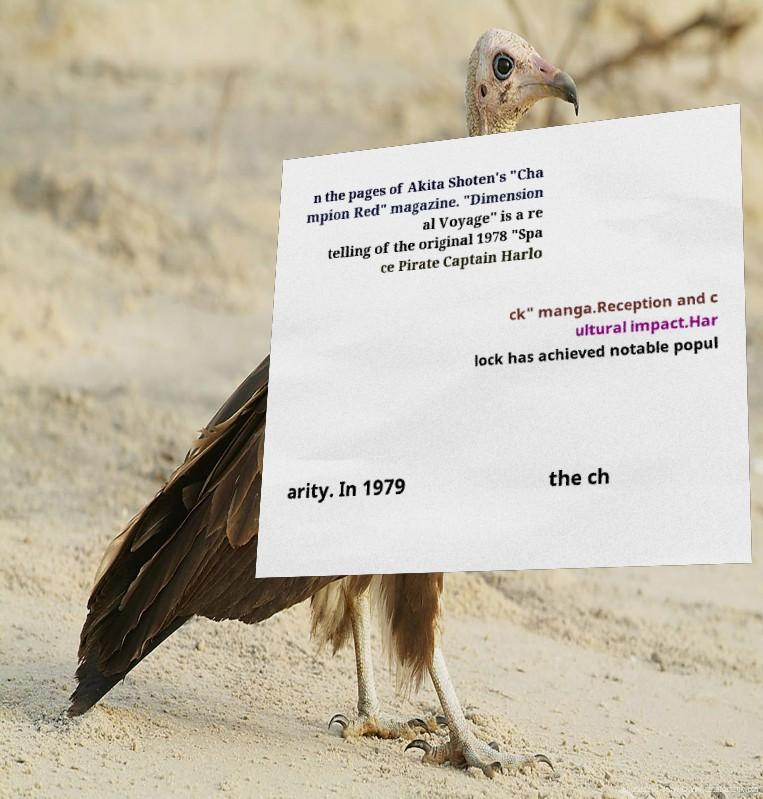For documentation purposes, I need the text within this image transcribed. Could you provide that? n the pages of Akita Shoten's "Cha mpion Red" magazine. "Dimension al Voyage" is a re telling of the original 1978 "Spa ce Pirate Captain Harlo ck" manga.Reception and c ultural impact.Har lock has achieved notable popul arity. In 1979 the ch 